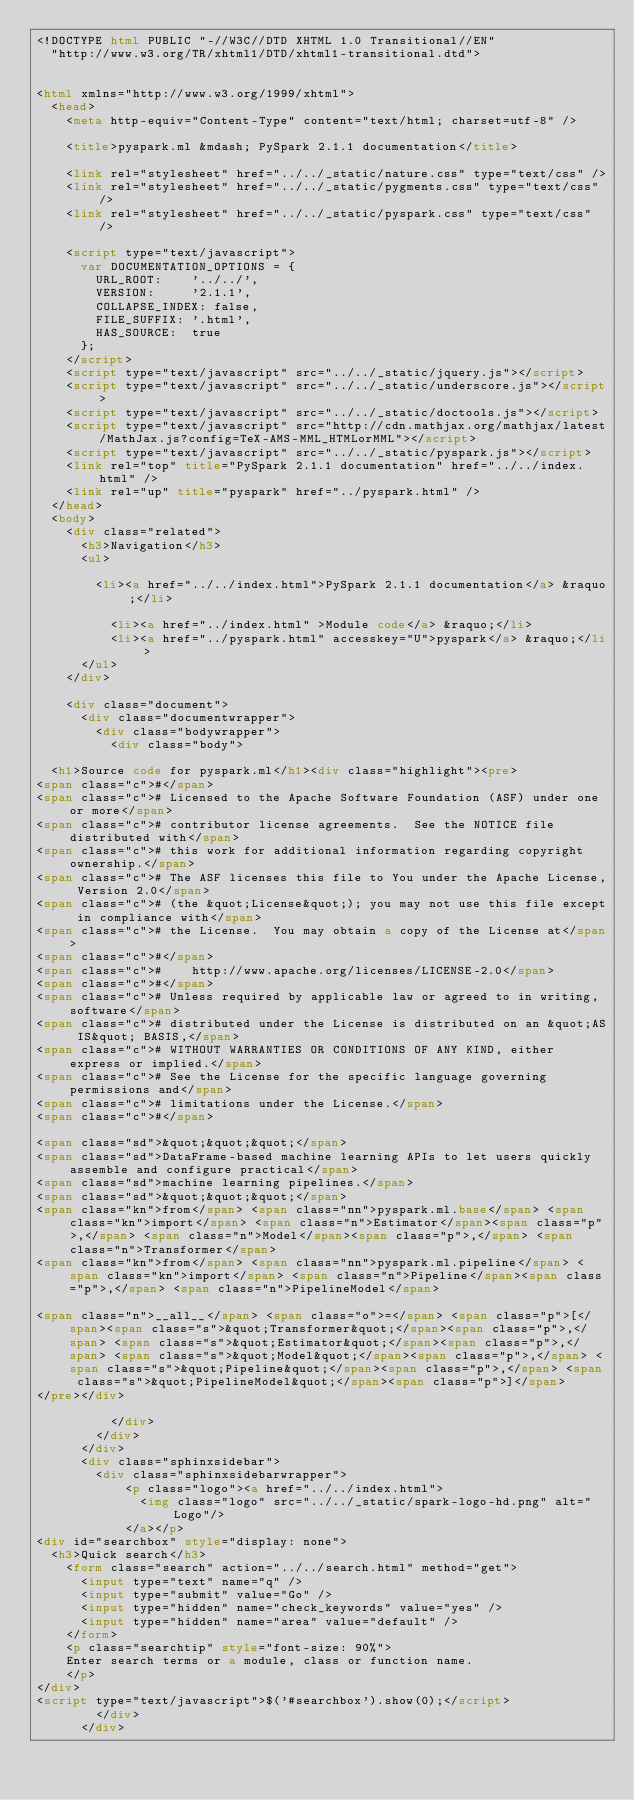Convert code to text. <code><loc_0><loc_0><loc_500><loc_500><_HTML_><!DOCTYPE html PUBLIC "-//W3C//DTD XHTML 1.0 Transitional//EN"
  "http://www.w3.org/TR/xhtml1/DTD/xhtml1-transitional.dtd">


<html xmlns="http://www.w3.org/1999/xhtml">
  <head>
    <meta http-equiv="Content-Type" content="text/html; charset=utf-8" />
    
    <title>pyspark.ml &mdash; PySpark 2.1.1 documentation</title>
    
    <link rel="stylesheet" href="../../_static/nature.css" type="text/css" />
    <link rel="stylesheet" href="../../_static/pygments.css" type="text/css" />
    <link rel="stylesheet" href="../../_static/pyspark.css" type="text/css" />
    
    <script type="text/javascript">
      var DOCUMENTATION_OPTIONS = {
        URL_ROOT:    '../../',
        VERSION:     '2.1.1',
        COLLAPSE_INDEX: false,
        FILE_SUFFIX: '.html',
        HAS_SOURCE:  true
      };
    </script>
    <script type="text/javascript" src="../../_static/jquery.js"></script>
    <script type="text/javascript" src="../../_static/underscore.js"></script>
    <script type="text/javascript" src="../../_static/doctools.js"></script>
    <script type="text/javascript" src="http://cdn.mathjax.org/mathjax/latest/MathJax.js?config=TeX-AMS-MML_HTMLorMML"></script>
    <script type="text/javascript" src="../../_static/pyspark.js"></script>
    <link rel="top" title="PySpark 2.1.1 documentation" href="../../index.html" />
    <link rel="up" title="pyspark" href="../pyspark.html" /> 
  </head>
  <body>
    <div class="related">
      <h3>Navigation</h3>
      <ul>
    
        <li><a href="../../index.html">PySpark 2.1.1 documentation</a> &raquo;</li>

          <li><a href="../index.html" >Module code</a> &raquo;</li>
          <li><a href="../pyspark.html" accesskey="U">pyspark</a> &raquo;</li> 
      </ul>
    </div>  

    <div class="document">
      <div class="documentwrapper">
        <div class="bodywrapper">
          <div class="body">
            
  <h1>Source code for pyspark.ml</h1><div class="highlight"><pre>
<span class="c">#</span>
<span class="c"># Licensed to the Apache Software Foundation (ASF) under one or more</span>
<span class="c"># contributor license agreements.  See the NOTICE file distributed with</span>
<span class="c"># this work for additional information regarding copyright ownership.</span>
<span class="c"># The ASF licenses this file to You under the Apache License, Version 2.0</span>
<span class="c"># (the &quot;License&quot;); you may not use this file except in compliance with</span>
<span class="c"># the License.  You may obtain a copy of the License at</span>
<span class="c">#</span>
<span class="c">#    http://www.apache.org/licenses/LICENSE-2.0</span>
<span class="c">#</span>
<span class="c"># Unless required by applicable law or agreed to in writing, software</span>
<span class="c"># distributed under the License is distributed on an &quot;AS IS&quot; BASIS,</span>
<span class="c"># WITHOUT WARRANTIES OR CONDITIONS OF ANY KIND, either express or implied.</span>
<span class="c"># See the License for the specific language governing permissions and</span>
<span class="c"># limitations under the License.</span>
<span class="c">#</span>

<span class="sd">&quot;&quot;&quot;</span>
<span class="sd">DataFrame-based machine learning APIs to let users quickly assemble and configure practical</span>
<span class="sd">machine learning pipelines.</span>
<span class="sd">&quot;&quot;&quot;</span>
<span class="kn">from</span> <span class="nn">pyspark.ml.base</span> <span class="kn">import</span> <span class="n">Estimator</span><span class="p">,</span> <span class="n">Model</span><span class="p">,</span> <span class="n">Transformer</span>
<span class="kn">from</span> <span class="nn">pyspark.ml.pipeline</span> <span class="kn">import</span> <span class="n">Pipeline</span><span class="p">,</span> <span class="n">PipelineModel</span>

<span class="n">__all__</span> <span class="o">=</span> <span class="p">[</span><span class="s">&quot;Transformer&quot;</span><span class="p">,</span> <span class="s">&quot;Estimator&quot;</span><span class="p">,</span> <span class="s">&quot;Model&quot;</span><span class="p">,</span> <span class="s">&quot;Pipeline&quot;</span><span class="p">,</span> <span class="s">&quot;PipelineModel&quot;</span><span class="p">]</span>
</pre></div>

          </div>
        </div>
      </div>
      <div class="sphinxsidebar">
        <div class="sphinxsidebarwrapper">
            <p class="logo"><a href="../../index.html">
              <img class="logo" src="../../_static/spark-logo-hd.png" alt="Logo"/>
            </a></p>
<div id="searchbox" style="display: none">
  <h3>Quick search</h3>
    <form class="search" action="../../search.html" method="get">
      <input type="text" name="q" />
      <input type="submit" value="Go" />
      <input type="hidden" name="check_keywords" value="yes" />
      <input type="hidden" name="area" value="default" />
    </form>
    <p class="searchtip" style="font-size: 90%">
    Enter search terms or a module, class or function name.
    </p>
</div>
<script type="text/javascript">$('#searchbox').show(0);</script>
        </div>
      </div></code> 